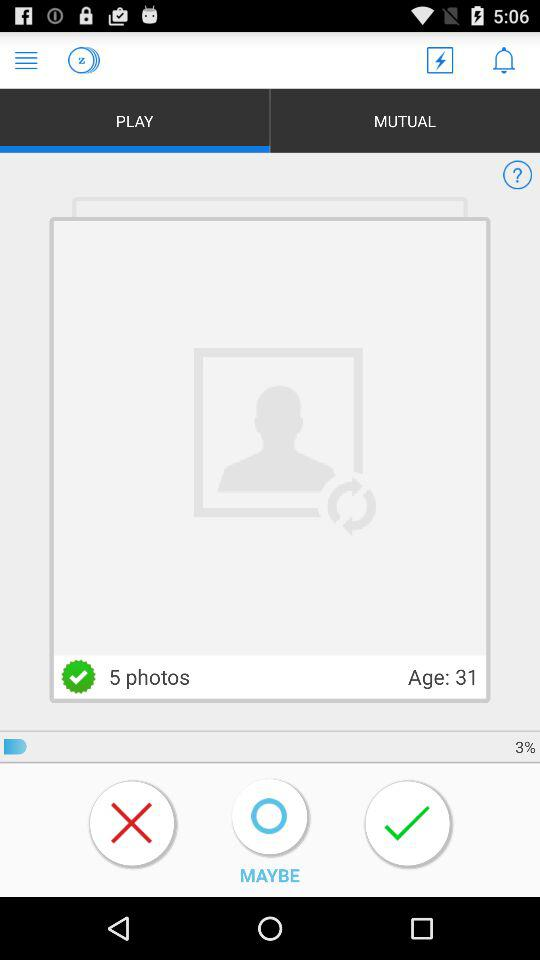What is the age? The age is 31. 